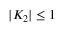<formula> <loc_0><loc_0><loc_500><loc_500>| K _ { 2 } | \leq 1</formula> 